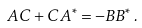Convert formula to latex. <formula><loc_0><loc_0><loc_500><loc_500>A C + C A ^ { \ast } = - B B ^ { \ast } \, .</formula> 